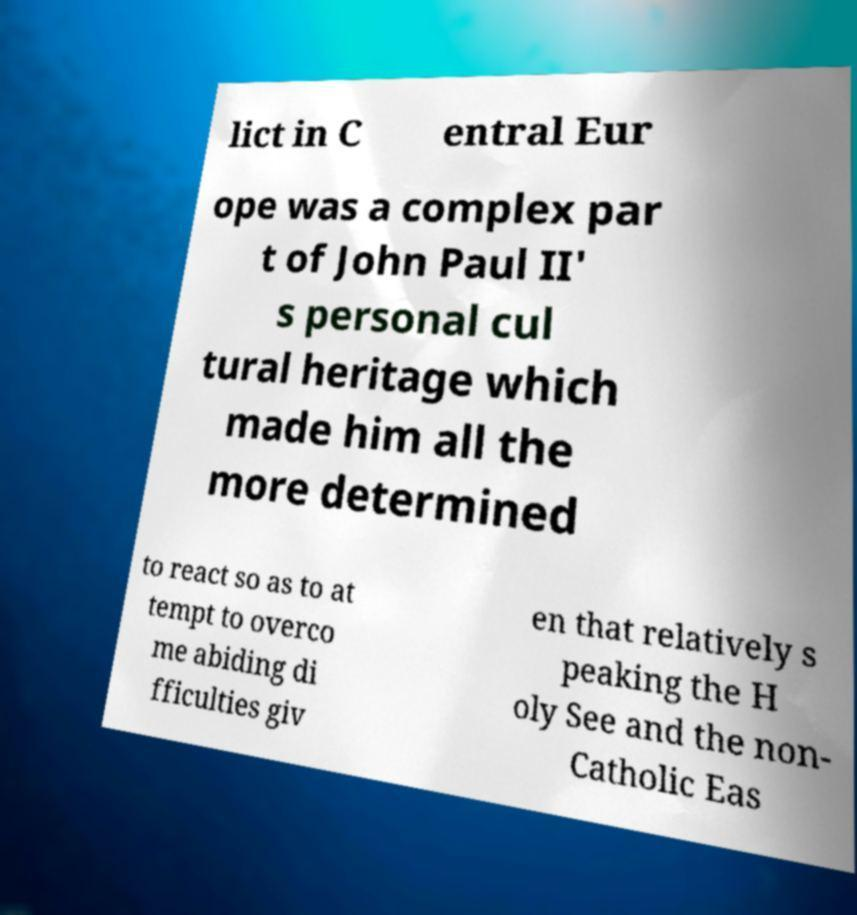Can you accurately transcribe the text from the provided image for me? lict in C entral Eur ope was a complex par t of John Paul II' s personal cul tural heritage which made him all the more determined to react so as to at tempt to overco me abiding di fficulties giv en that relatively s peaking the H oly See and the non- Catholic Eas 